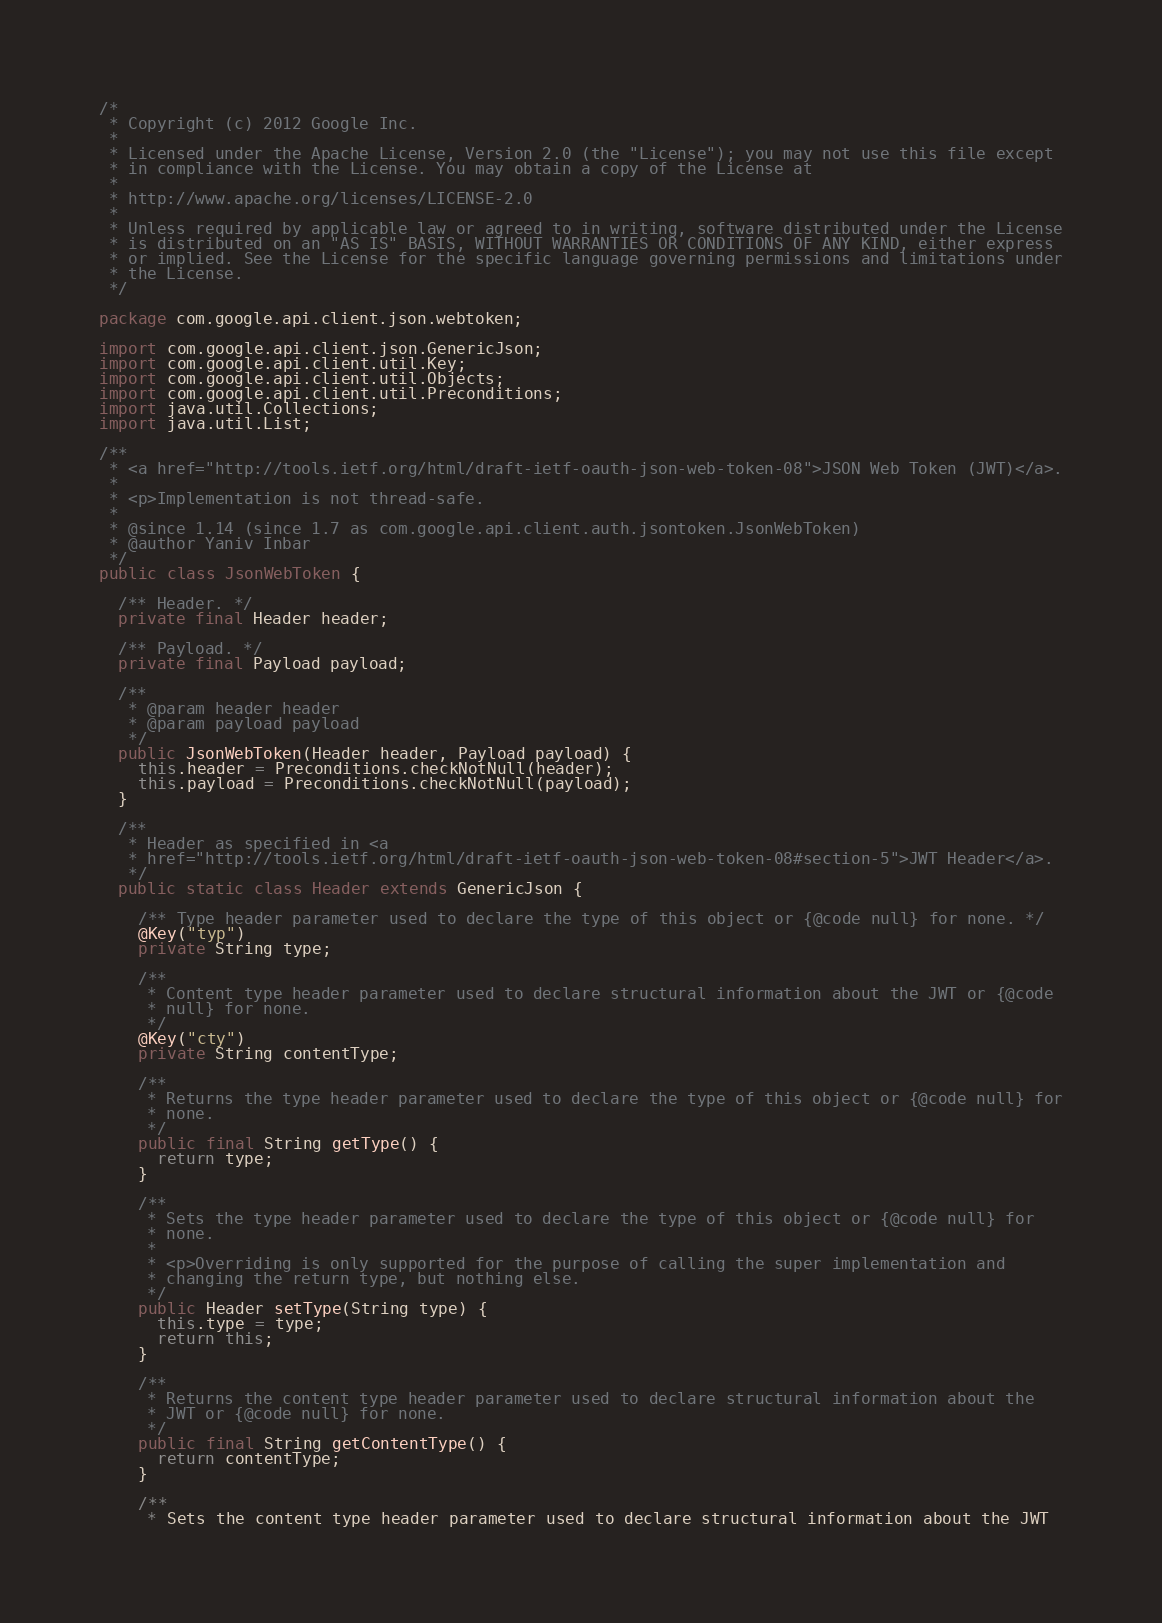<code> <loc_0><loc_0><loc_500><loc_500><_Java_>/*
 * Copyright (c) 2012 Google Inc.
 *
 * Licensed under the Apache License, Version 2.0 (the "License"); you may not use this file except
 * in compliance with the License. You may obtain a copy of the License at
 *
 * http://www.apache.org/licenses/LICENSE-2.0
 *
 * Unless required by applicable law or agreed to in writing, software distributed under the License
 * is distributed on an "AS IS" BASIS, WITHOUT WARRANTIES OR CONDITIONS OF ANY KIND, either express
 * or implied. See the License for the specific language governing permissions and limitations under
 * the License.
 */

package com.google.api.client.json.webtoken;

import com.google.api.client.json.GenericJson;
import com.google.api.client.util.Key;
import com.google.api.client.util.Objects;
import com.google.api.client.util.Preconditions;
import java.util.Collections;
import java.util.List;

/**
 * <a href="http://tools.ietf.org/html/draft-ietf-oauth-json-web-token-08">JSON Web Token (JWT)</a>.
 *
 * <p>Implementation is not thread-safe.
 *
 * @since 1.14 (since 1.7 as com.google.api.client.auth.jsontoken.JsonWebToken)
 * @author Yaniv Inbar
 */
public class JsonWebToken {

  /** Header. */
  private final Header header;

  /** Payload. */
  private final Payload payload;

  /**
   * @param header header
   * @param payload payload
   */
  public JsonWebToken(Header header, Payload payload) {
    this.header = Preconditions.checkNotNull(header);
    this.payload = Preconditions.checkNotNull(payload);
  }

  /**
   * Header as specified in <a
   * href="http://tools.ietf.org/html/draft-ietf-oauth-json-web-token-08#section-5">JWT Header</a>.
   */
  public static class Header extends GenericJson {

    /** Type header parameter used to declare the type of this object or {@code null} for none. */
    @Key("typ")
    private String type;

    /**
     * Content type header parameter used to declare structural information about the JWT or {@code
     * null} for none.
     */
    @Key("cty")
    private String contentType;

    /**
     * Returns the type header parameter used to declare the type of this object or {@code null} for
     * none.
     */
    public final String getType() {
      return type;
    }

    /**
     * Sets the type header parameter used to declare the type of this object or {@code null} for
     * none.
     *
     * <p>Overriding is only supported for the purpose of calling the super implementation and
     * changing the return type, but nothing else.
     */
    public Header setType(String type) {
      this.type = type;
      return this;
    }

    /**
     * Returns the content type header parameter used to declare structural information about the
     * JWT or {@code null} for none.
     */
    public final String getContentType() {
      return contentType;
    }

    /**
     * Sets the content type header parameter used to declare structural information about the JWT</code> 